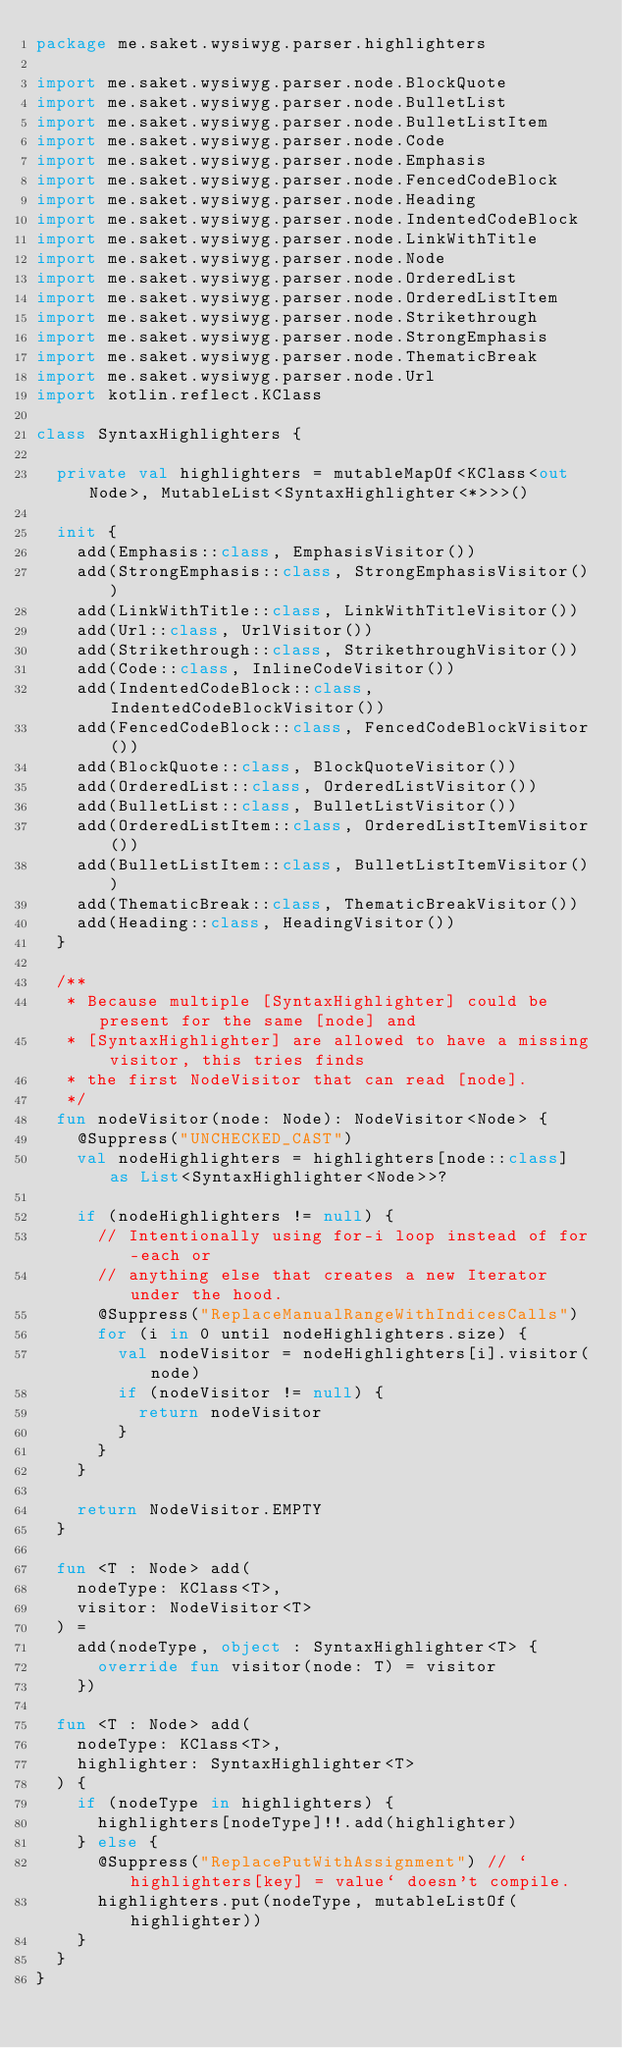Convert code to text. <code><loc_0><loc_0><loc_500><loc_500><_Kotlin_>package me.saket.wysiwyg.parser.highlighters

import me.saket.wysiwyg.parser.node.BlockQuote
import me.saket.wysiwyg.parser.node.BulletList
import me.saket.wysiwyg.parser.node.BulletListItem
import me.saket.wysiwyg.parser.node.Code
import me.saket.wysiwyg.parser.node.Emphasis
import me.saket.wysiwyg.parser.node.FencedCodeBlock
import me.saket.wysiwyg.parser.node.Heading
import me.saket.wysiwyg.parser.node.IndentedCodeBlock
import me.saket.wysiwyg.parser.node.LinkWithTitle
import me.saket.wysiwyg.parser.node.Node
import me.saket.wysiwyg.parser.node.OrderedList
import me.saket.wysiwyg.parser.node.OrderedListItem
import me.saket.wysiwyg.parser.node.Strikethrough
import me.saket.wysiwyg.parser.node.StrongEmphasis
import me.saket.wysiwyg.parser.node.ThematicBreak
import me.saket.wysiwyg.parser.node.Url
import kotlin.reflect.KClass

class SyntaxHighlighters {

  private val highlighters = mutableMapOf<KClass<out Node>, MutableList<SyntaxHighlighter<*>>>()

  init {
    add(Emphasis::class, EmphasisVisitor())
    add(StrongEmphasis::class, StrongEmphasisVisitor())
    add(LinkWithTitle::class, LinkWithTitleVisitor())
    add(Url::class, UrlVisitor())
    add(Strikethrough::class, StrikethroughVisitor())
    add(Code::class, InlineCodeVisitor())
    add(IndentedCodeBlock::class, IndentedCodeBlockVisitor())
    add(FencedCodeBlock::class, FencedCodeBlockVisitor())
    add(BlockQuote::class, BlockQuoteVisitor())
    add(OrderedList::class, OrderedListVisitor())
    add(BulletList::class, BulletListVisitor())
    add(OrderedListItem::class, OrderedListItemVisitor())
    add(BulletListItem::class, BulletListItemVisitor())
    add(ThematicBreak::class, ThematicBreakVisitor())
    add(Heading::class, HeadingVisitor())
  }

  /**
   * Because multiple [SyntaxHighlighter] could be present for the same [node] and
   * [SyntaxHighlighter] are allowed to have a missing visitor, this tries finds
   * the first NodeVisitor that can read [node].
   */
  fun nodeVisitor(node: Node): NodeVisitor<Node> {
    @Suppress("UNCHECKED_CAST")
    val nodeHighlighters = highlighters[node::class] as List<SyntaxHighlighter<Node>>?

    if (nodeHighlighters != null) {
      // Intentionally using for-i loop instead of for-each or
      // anything else that creates a new Iterator under the hood.
      @Suppress("ReplaceManualRangeWithIndicesCalls")
      for (i in 0 until nodeHighlighters.size) {
        val nodeVisitor = nodeHighlighters[i].visitor(node)
        if (nodeVisitor != null) {
          return nodeVisitor
        }
      }
    }

    return NodeVisitor.EMPTY
  }

  fun <T : Node> add(
    nodeType: KClass<T>,
    visitor: NodeVisitor<T>
  ) =
    add(nodeType, object : SyntaxHighlighter<T> {
      override fun visitor(node: T) = visitor
    })

  fun <T : Node> add(
    nodeType: KClass<T>,
    highlighter: SyntaxHighlighter<T>
  ) {
    if (nodeType in highlighters) {
      highlighters[nodeType]!!.add(highlighter)
    } else {
      @Suppress("ReplacePutWithAssignment") // `highlighters[key] = value` doesn't compile.
      highlighters.put(nodeType, mutableListOf(highlighter))
    }
  }
}
</code> 